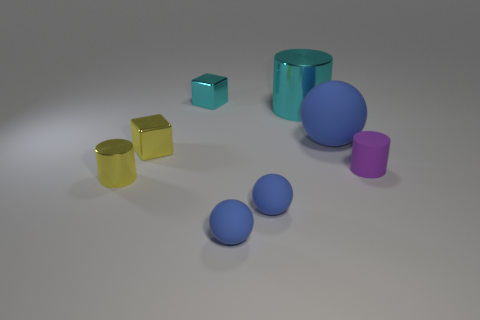Is the color of the object to the right of the large blue ball the same as the shiny cylinder that is behind the yellow metal cylinder?
Provide a succinct answer. No. There is a small block in front of the large cylinder; are there any big balls that are behind it?
Give a very brief answer. Yes. Are there fewer tiny blue rubber spheres that are left of the cyan metallic block than small rubber cylinders in front of the small purple thing?
Offer a terse response. No. Is the material of the blue sphere to the right of the cyan metal cylinder the same as the yellow thing that is behind the purple rubber object?
Your answer should be compact. No. What number of small things are brown shiny blocks or matte things?
Give a very brief answer. 3. What shape is the yellow thing that is the same material as the tiny yellow cylinder?
Ensure brevity in your answer.  Cube. Are there fewer purple rubber things on the right side of the cyan metallic cylinder than large cyan shiny things?
Ensure brevity in your answer.  No. Do the purple object and the big blue object have the same shape?
Make the answer very short. No. What number of metallic things are either tiny purple things or blue balls?
Give a very brief answer. 0. Is there a purple shiny cube of the same size as the yellow block?
Keep it short and to the point. No. 